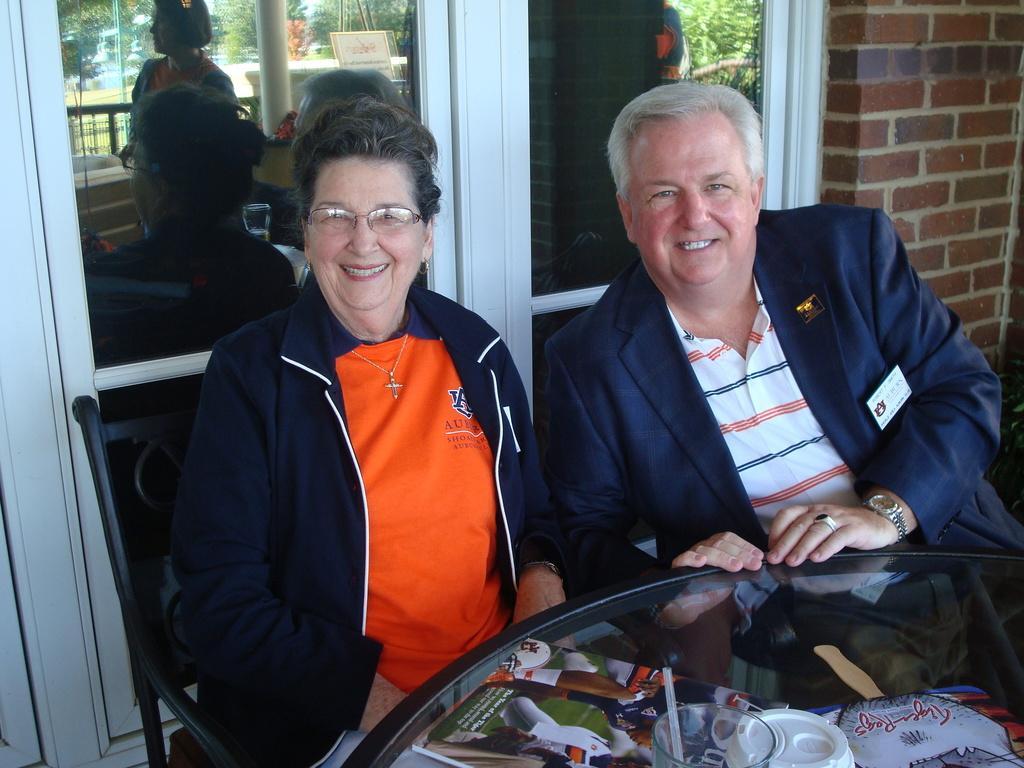In one or two sentences, can you explain what this image depicts? In this image in the foreground there is one woman and one man who are sitting on chairs, in front of them there is one table. On the table there is one magazine, cup, straw and one book. In the background there is a glass window and a wall. 